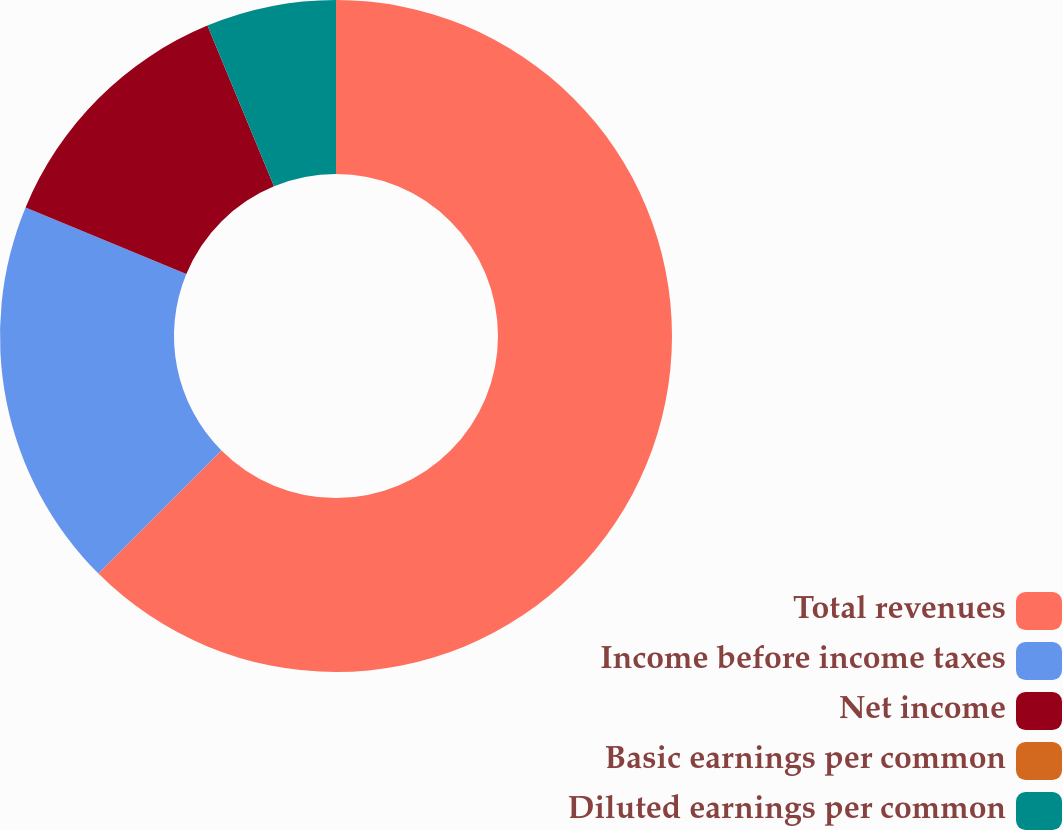Convert chart. <chart><loc_0><loc_0><loc_500><loc_500><pie_chart><fcel>Total revenues<fcel>Income before income taxes<fcel>Net income<fcel>Basic earnings per common<fcel>Diluted earnings per common<nl><fcel>62.5%<fcel>18.75%<fcel>12.5%<fcel>0.0%<fcel>6.25%<nl></chart> 